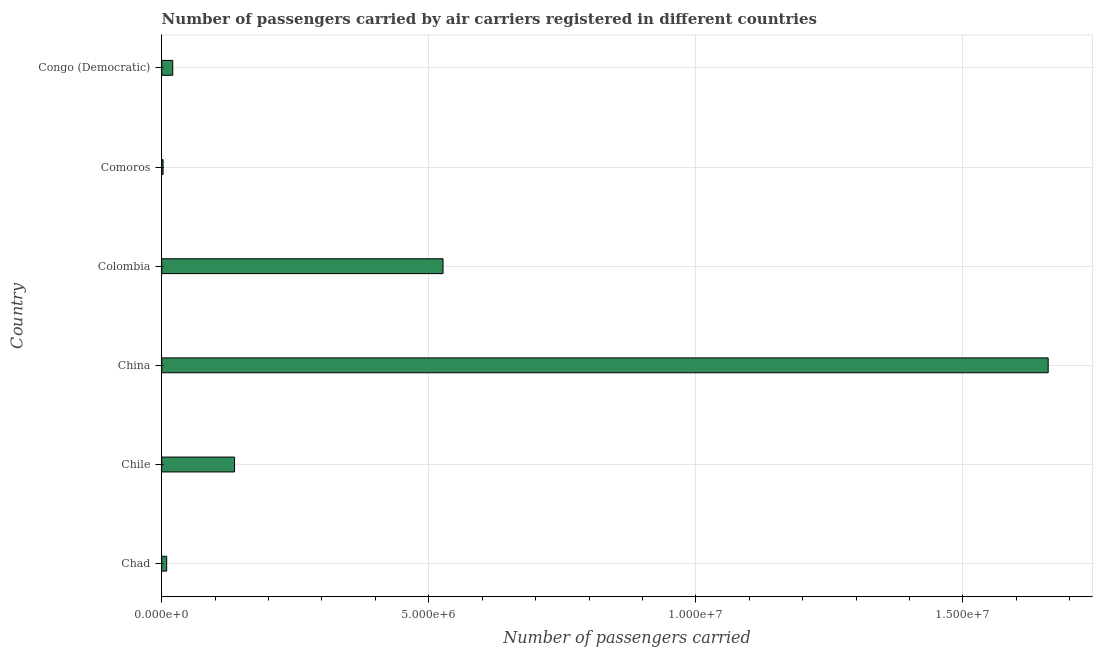What is the title of the graph?
Offer a very short reply. Number of passengers carried by air carriers registered in different countries. What is the label or title of the X-axis?
Your response must be concise. Number of passengers carried. What is the number of passengers carried in Chad?
Provide a succinct answer. 9.33e+04. Across all countries, what is the maximum number of passengers carried?
Provide a succinct answer. 1.66e+07. Across all countries, what is the minimum number of passengers carried?
Your response must be concise. 2.60e+04. In which country was the number of passengers carried maximum?
Provide a short and direct response. China. In which country was the number of passengers carried minimum?
Provide a succinct answer. Comoros. What is the sum of the number of passengers carried?
Provide a short and direct response. 2.36e+07. What is the difference between the number of passengers carried in Chad and Colombia?
Provide a short and direct response. -5.17e+06. What is the average number of passengers carried per country?
Offer a very short reply. 3.93e+06. What is the median number of passengers carried?
Give a very brief answer. 7.85e+05. What is the ratio of the number of passengers carried in Chile to that in Comoros?
Your answer should be very brief. 52.45. Is the number of passengers carried in China less than that in Comoros?
Offer a very short reply. No. Is the difference between the number of passengers carried in Colombia and Congo (Democratic) greater than the difference between any two countries?
Provide a succinct answer. No. What is the difference between the highest and the second highest number of passengers carried?
Provide a succinct answer. 1.13e+07. What is the difference between the highest and the lowest number of passengers carried?
Offer a very short reply. 1.66e+07. How many bars are there?
Your answer should be compact. 6. What is the difference between two consecutive major ticks on the X-axis?
Offer a very short reply. 5.00e+06. What is the Number of passengers carried of Chad?
Provide a succinct answer. 9.33e+04. What is the Number of passengers carried in Chile?
Your answer should be very brief. 1.36e+06. What is the Number of passengers carried in China?
Your response must be concise. 1.66e+07. What is the Number of passengers carried in Colombia?
Give a very brief answer. 5.27e+06. What is the Number of passengers carried of Comoros?
Provide a succinct answer. 2.60e+04. What is the Number of passengers carried in Congo (Democratic)?
Make the answer very short. 2.07e+05. What is the difference between the Number of passengers carried in Chad and Chile?
Provide a short and direct response. -1.27e+06. What is the difference between the Number of passengers carried in Chad and China?
Your answer should be compact. -1.65e+07. What is the difference between the Number of passengers carried in Chad and Colombia?
Provide a succinct answer. -5.17e+06. What is the difference between the Number of passengers carried in Chad and Comoros?
Your answer should be compact. 6.73e+04. What is the difference between the Number of passengers carried in Chad and Congo (Democratic)?
Offer a very short reply. -1.13e+05. What is the difference between the Number of passengers carried in Chile and China?
Keep it short and to the point. -1.52e+07. What is the difference between the Number of passengers carried in Chile and Colombia?
Keep it short and to the point. -3.90e+06. What is the difference between the Number of passengers carried in Chile and Comoros?
Your response must be concise. 1.34e+06. What is the difference between the Number of passengers carried in Chile and Congo (Democratic)?
Offer a very short reply. 1.16e+06. What is the difference between the Number of passengers carried in China and Colombia?
Offer a terse response. 1.13e+07. What is the difference between the Number of passengers carried in China and Comoros?
Give a very brief answer. 1.66e+07. What is the difference between the Number of passengers carried in China and Congo (Democratic)?
Provide a succinct answer. 1.64e+07. What is the difference between the Number of passengers carried in Colombia and Comoros?
Offer a very short reply. 5.24e+06. What is the difference between the Number of passengers carried in Colombia and Congo (Democratic)?
Offer a very short reply. 5.06e+06. What is the difference between the Number of passengers carried in Comoros and Congo (Democratic)?
Ensure brevity in your answer.  -1.81e+05. What is the ratio of the Number of passengers carried in Chad to that in Chile?
Provide a succinct answer. 0.07. What is the ratio of the Number of passengers carried in Chad to that in China?
Your answer should be very brief. 0.01. What is the ratio of the Number of passengers carried in Chad to that in Colombia?
Your response must be concise. 0.02. What is the ratio of the Number of passengers carried in Chad to that in Comoros?
Give a very brief answer. 3.59. What is the ratio of the Number of passengers carried in Chad to that in Congo (Democratic)?
Provide a short and direct response. 0.45. What is the ratio of the Number of passengers carried in Chile to that in China?
Your answer should be very brief. 0.08. What is the ratio of the Number of passengers carried in Chile to that in Colombia?
Offer a very short reply. 0.26. What is the ratio of the Number of passengers carried in Chile to that in Comoros?
Ensure brevity in your answer.  52.45. What is the ratio of the Number of passengers carried in Chile to that in Congo (Democratic)?
Make the answer very short. 6.6. What is the ratio of the Number of passengers carried in China to that in Colombia?
Provide a short and direct response. 3.15. What is the ratio of the Number of passengers carried in China to that in Comoros?
Your response must be concise. 638.31. What is the ratio of the Number of passengers carried in China to that in Congo (Democratic)?
Your answer should be very brief. 80.29. What is the ratio of the Number of passengers carried in Colombia to that in Comoros?
Your response must be concise. 202.56. What is the ratio of the Number of passengers carried in Colombia to that in Congo (Democratic)?
Keep it short and to the point. 25.48. What is the ratio of the Number of passengers carried in Comoros to that in Congo (Democratic)?
Your answer should be compact. 0.13. 